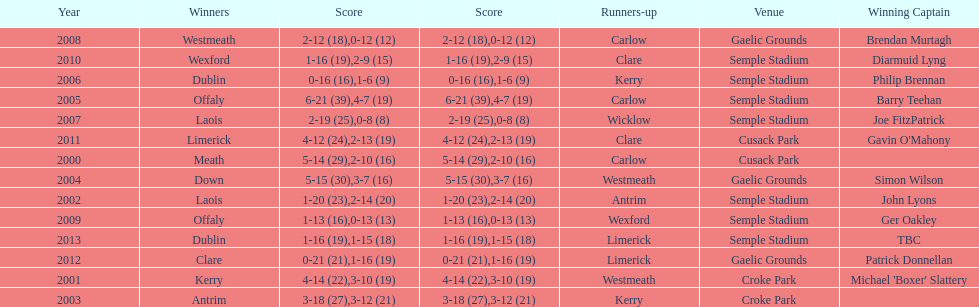Which team was the previous winner before dublin in 2013? Clare. 